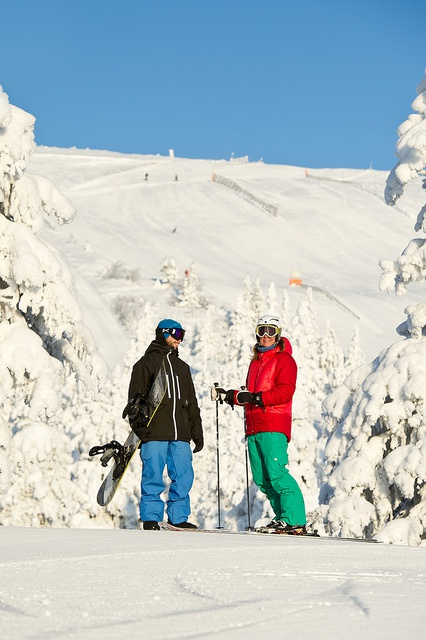Describe the objects in this image and their specific colors. I can see people in gray, black, and teal tones, people in gray, red, teal, black, and turquoise tones, snowboard in gray, black, darkgray, and darkgreen tones, skis in gray, darkgray, lightgray, and black tones, and skis in gray, darkgray, tan, and lightgray tones in this image. 